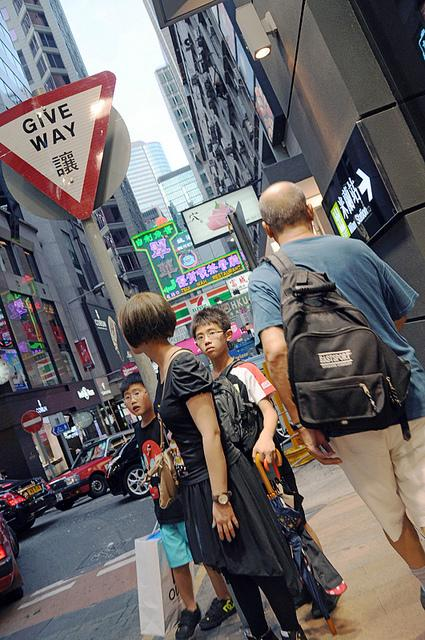The neon signs on the street are located in which city in Asia? Please explain your reasoning. hong kong. The signs are in hong kong. 